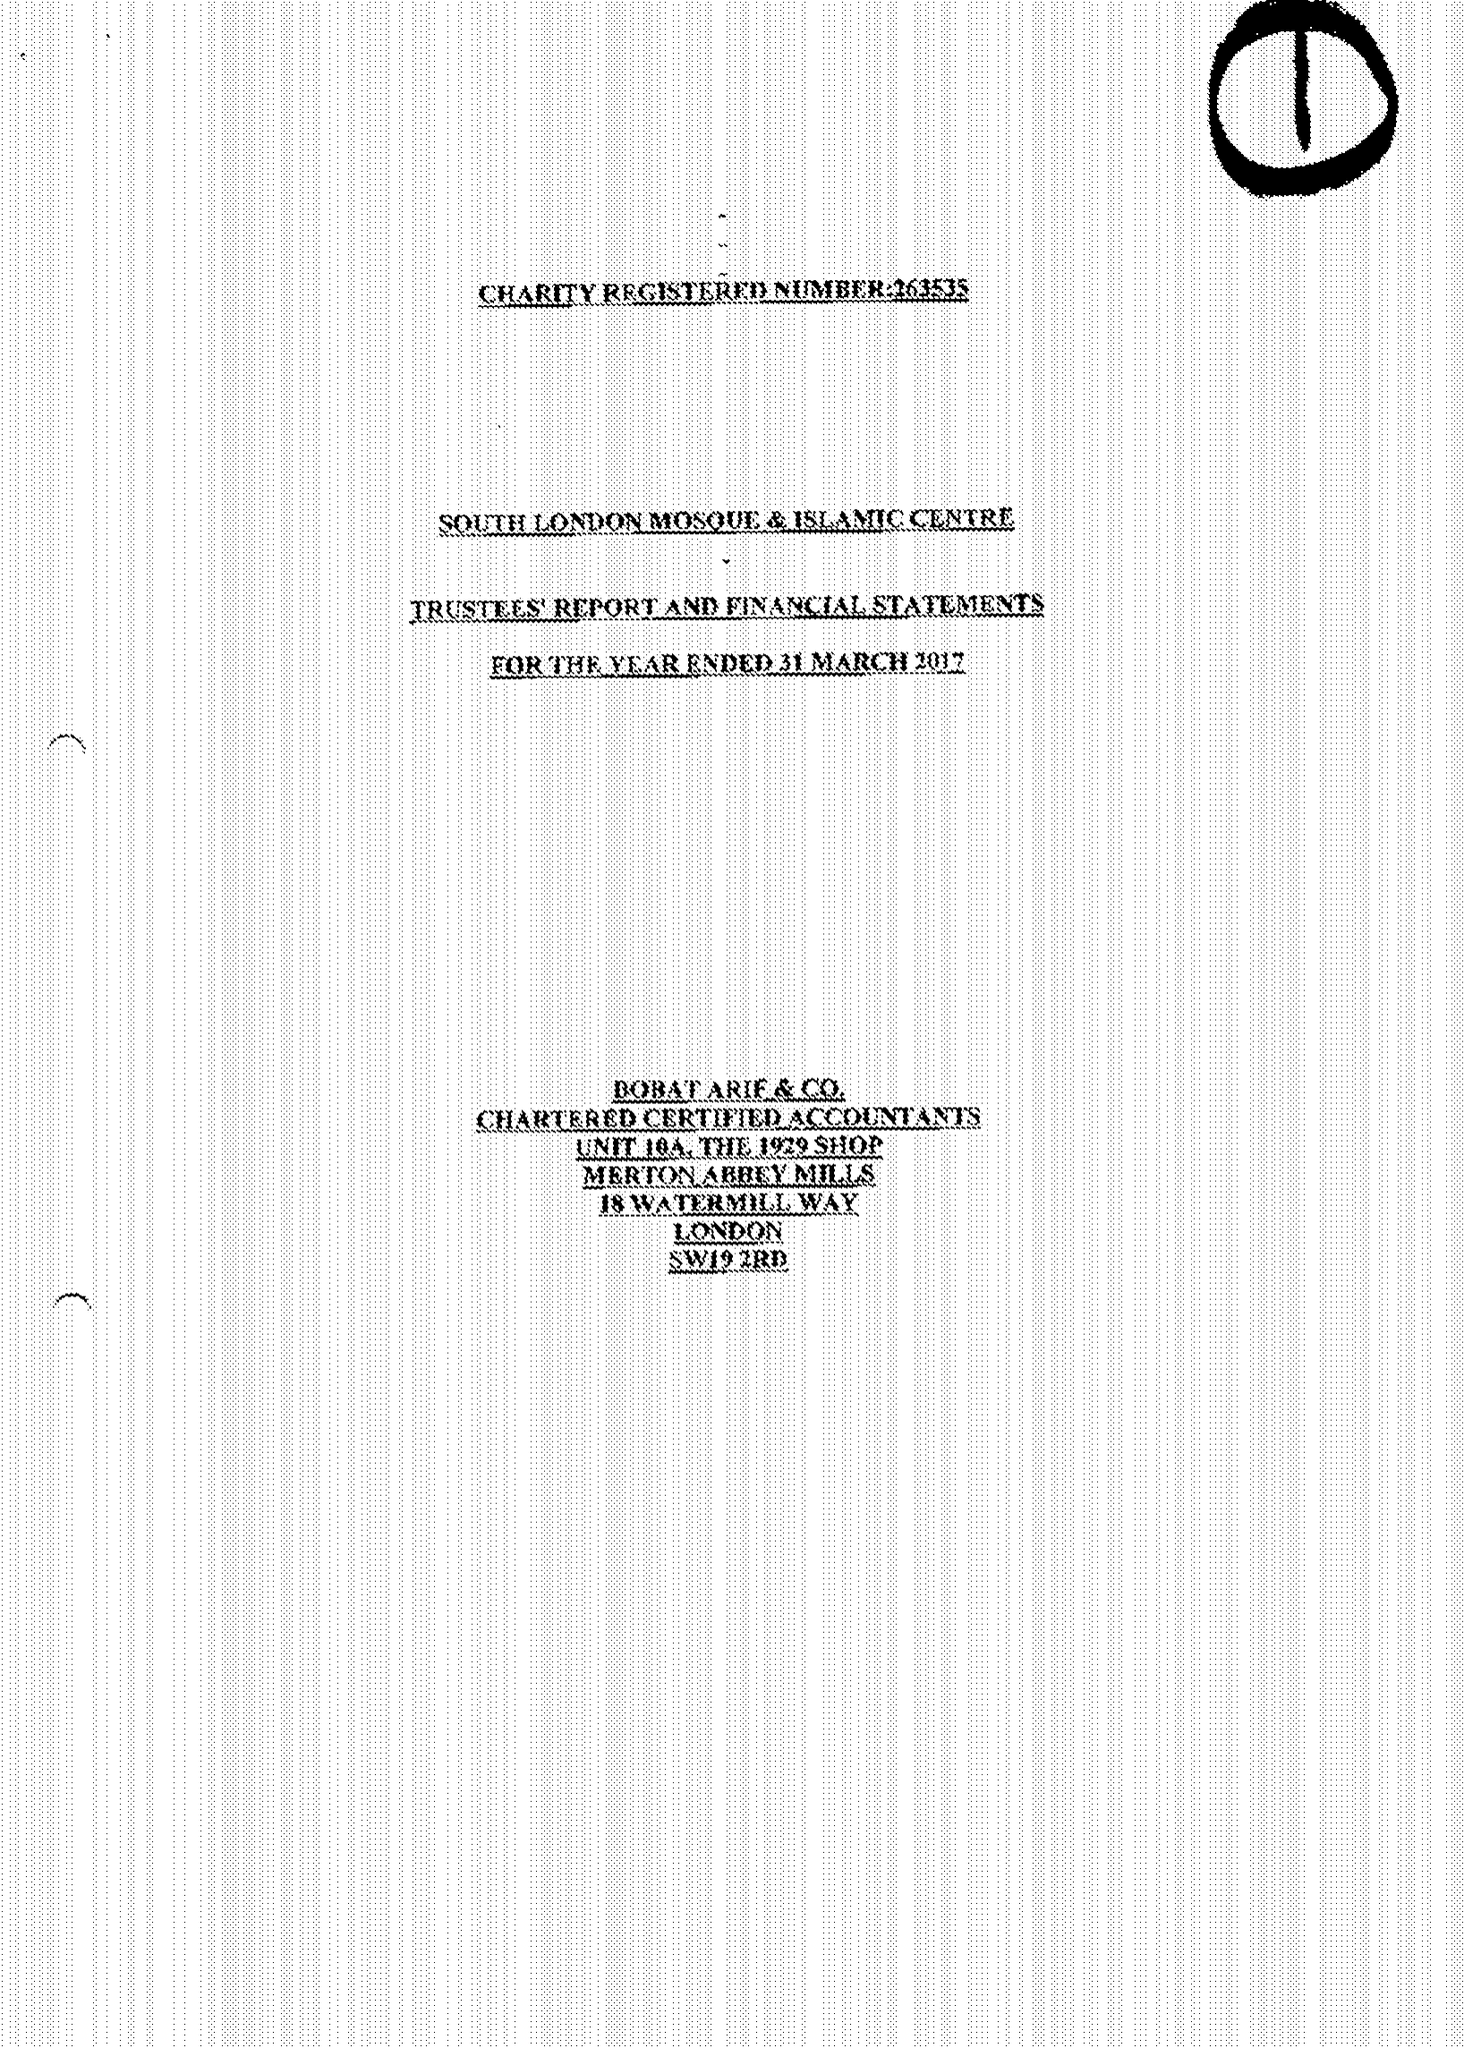What is the value for the spending_annually_in_british_pounds?
Answer the question using a single word or phrase. 246004.00 